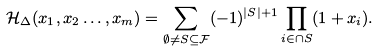<formula> <loc_0><loc_0><loc_500><loc_500>\mathcal { H } _ { \Delta } ( x _ { 1 } , x _ { 2 } \dots , x _ { m } ) = \sum _ { \emptyset \neq S \subseteq \mathcal { F } } ( - 1 ) ^ { | S | + 1 } \prod _ { i \in \cap S } ( 1 + x _ { i } ) .</formula> 